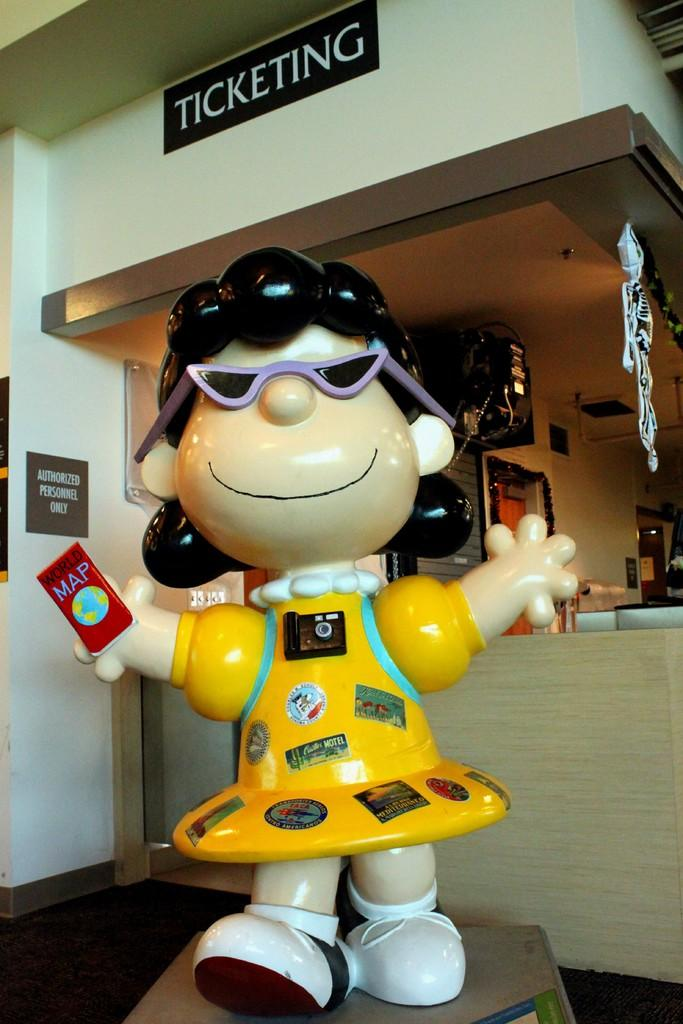What type of toy is present in the image? There is a toy in the image. What accessory is visible in the image? There are goggles in the image. What electronic device can be seen in the image? There is a device in the image. What are the name boards used for in the image? The name boards are used for identification or labeling in the image. What additional objects can be seen behind the toy? There are other objects visible at the back of the toy. What type of blade is being used to gain approval in the image? There is no blade or approval process present in the image. How does the device attract attention in the image? The device does not actively attract attention in the image; it is just one of the objects present. 